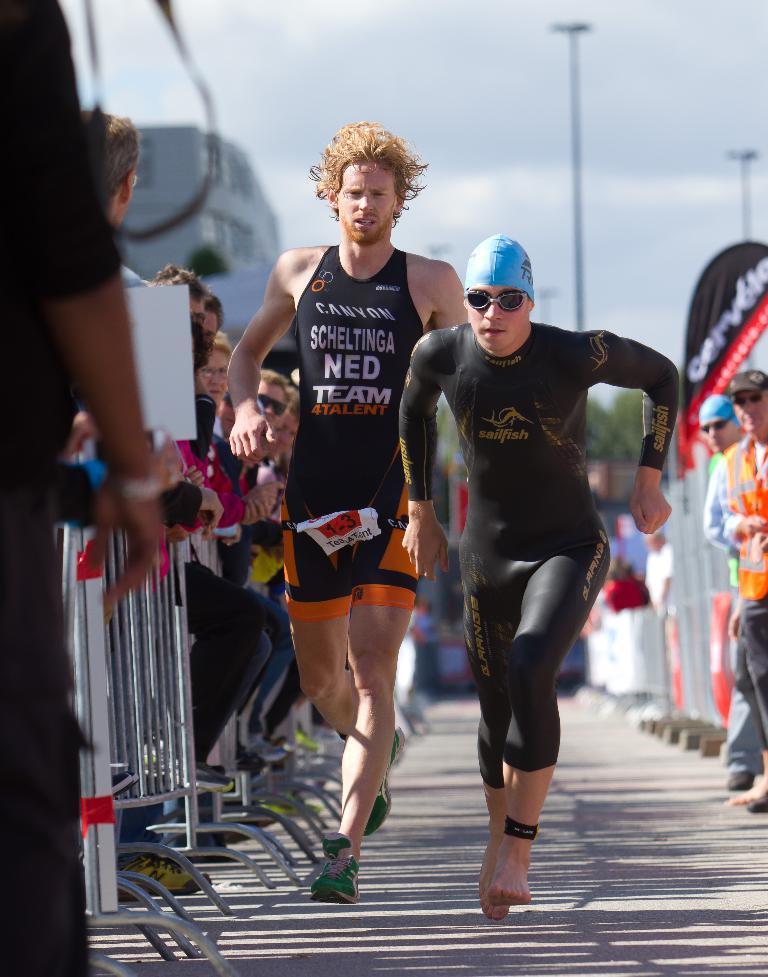Please provide a concise description of this image. This image is taken outdoors. At the bottom of the image there is a road. At the top of the image there is a sky with clouds. In the middle of the image two men are running on the ground. On the left side of the image there is a railing and a few people are standing on the road. On the right side of the image there are two poles and two men are standing on the road and there is a board with a text on it. 